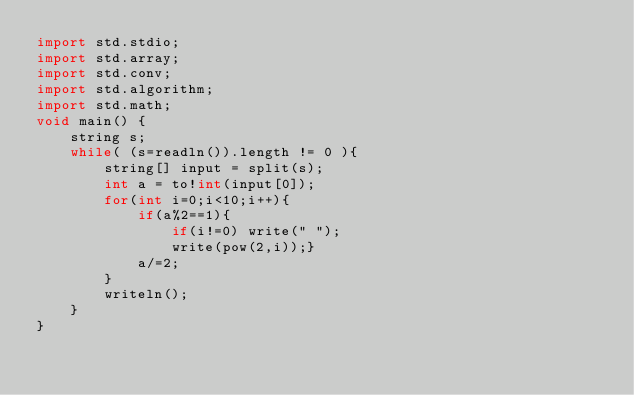<code> <loc_0><loc_0><loc_500><loc_500><_D_>import std.stdio;
import std.array;
import std.conv;
import std.algorithm;
import std.math;
void main() {
	string s;
	while( (s=readln()).length != 0 ){
		string[] input = split(s);
		int a = to!int(input[0]);
		for(int i=0;i<10;i++){
			if(a%2==1){
				if(i!=0) write(" ");
				write(pow(2,i));}
			a/=2;
		}
		writeln();
	}
}</code> 